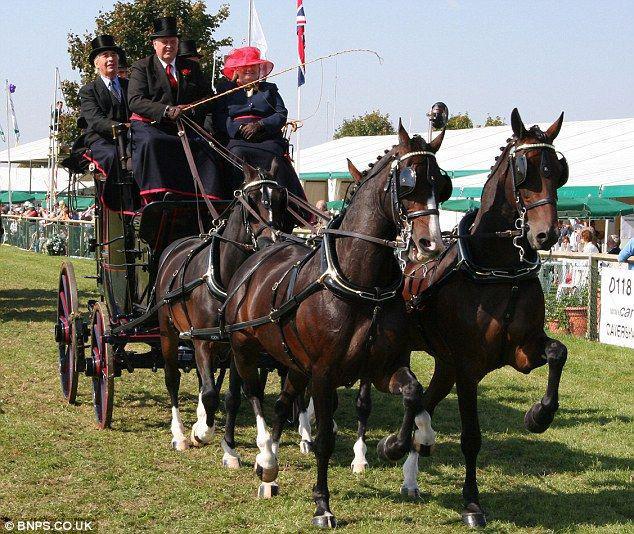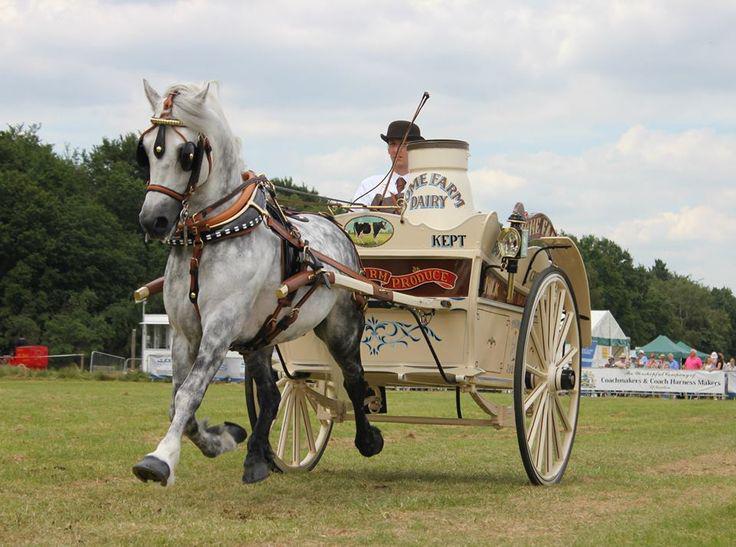The first image is the image on the left, the second image is the image on the right. For the images shown, is this caption "The carriages are being pulled by brown horses." true? Answer yes or no. No. The first image is the image on the left, the second image is the image on the right. Given the left and right images, does the statement "At least one wagon is carrying more than one person." hold true? Answer yes or no. Yes. 